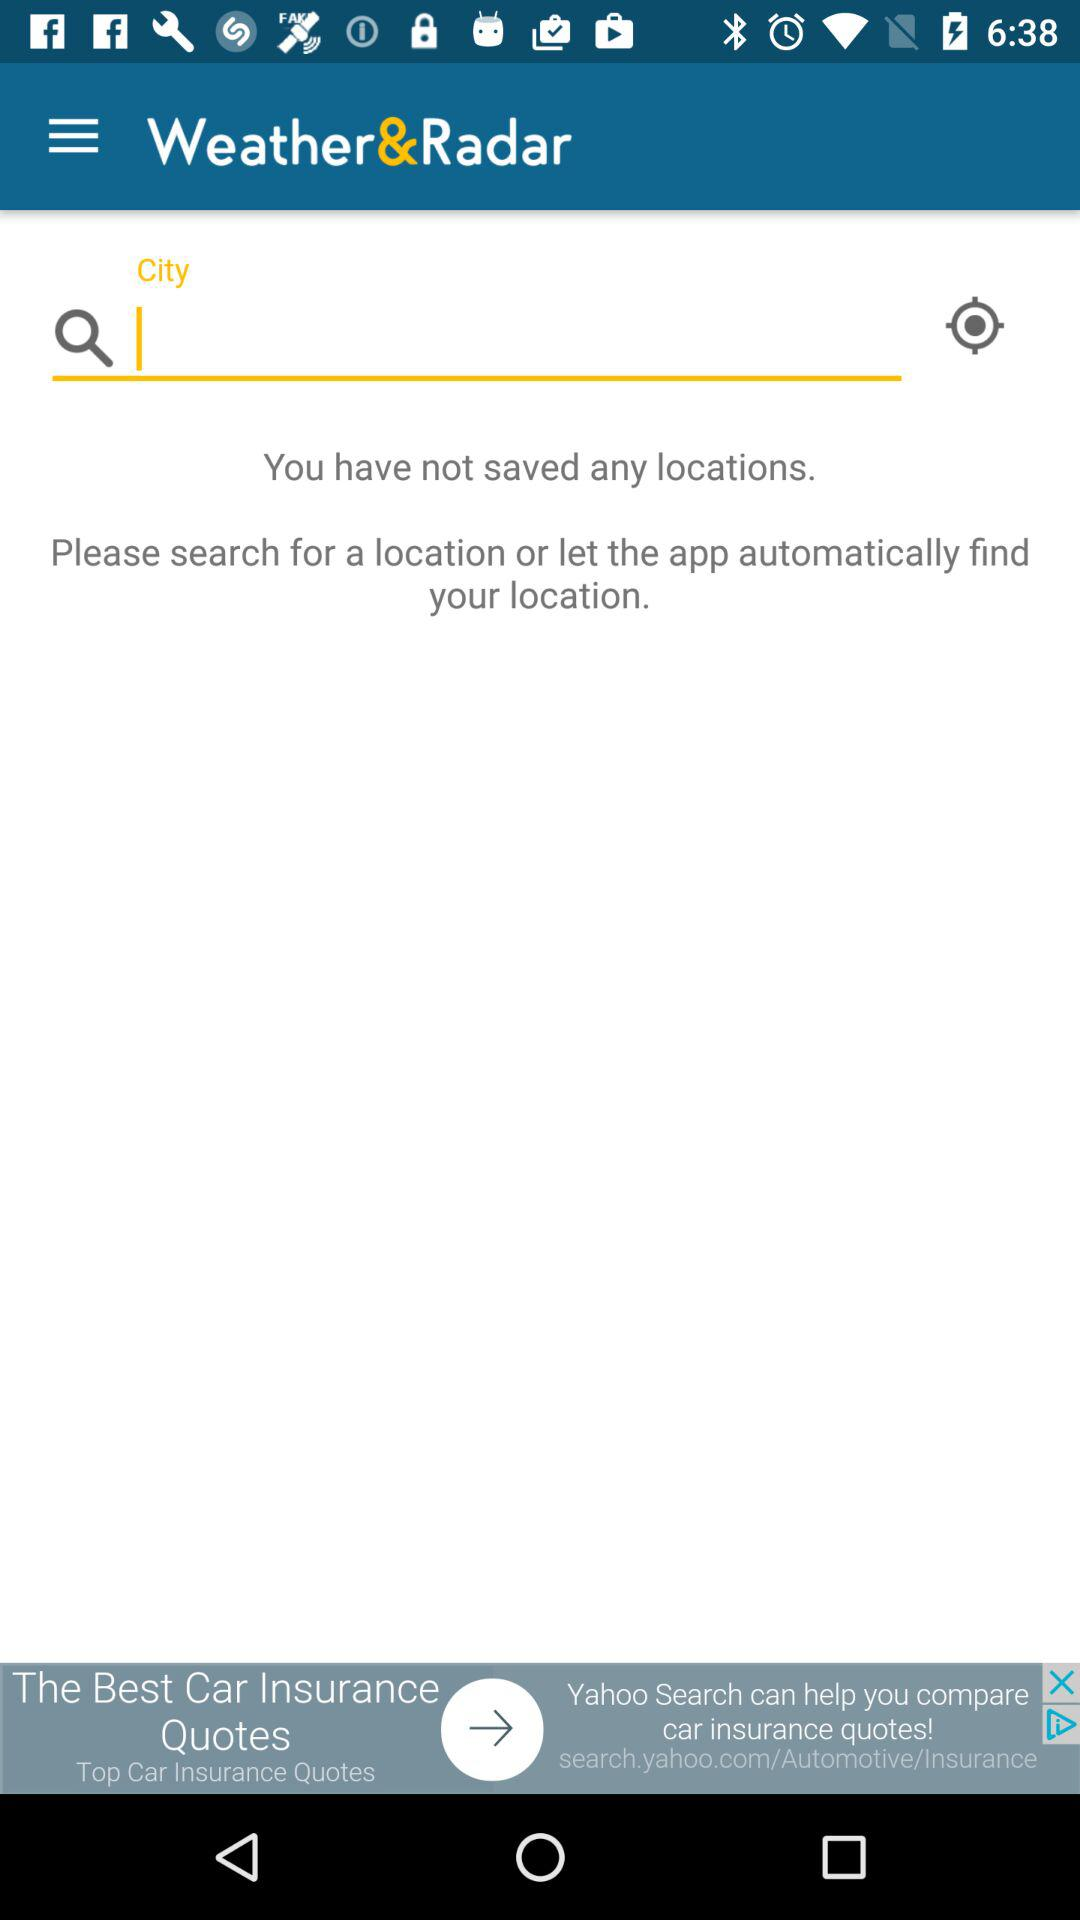How many locations have been saved?
Answer the question using a single word or phrase. 0 